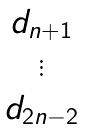Convert formula to latex. <formula><loc_0><loc_0><loc_500><loc_500>\begin{matrix} d _ { n + 1 } \\ \vdots \\ d _ { 2 n - 2 } \end{matrix}</formula> 